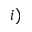<formula> <loc_0><loc_0><loc_500><loc_500>i )</formula> 